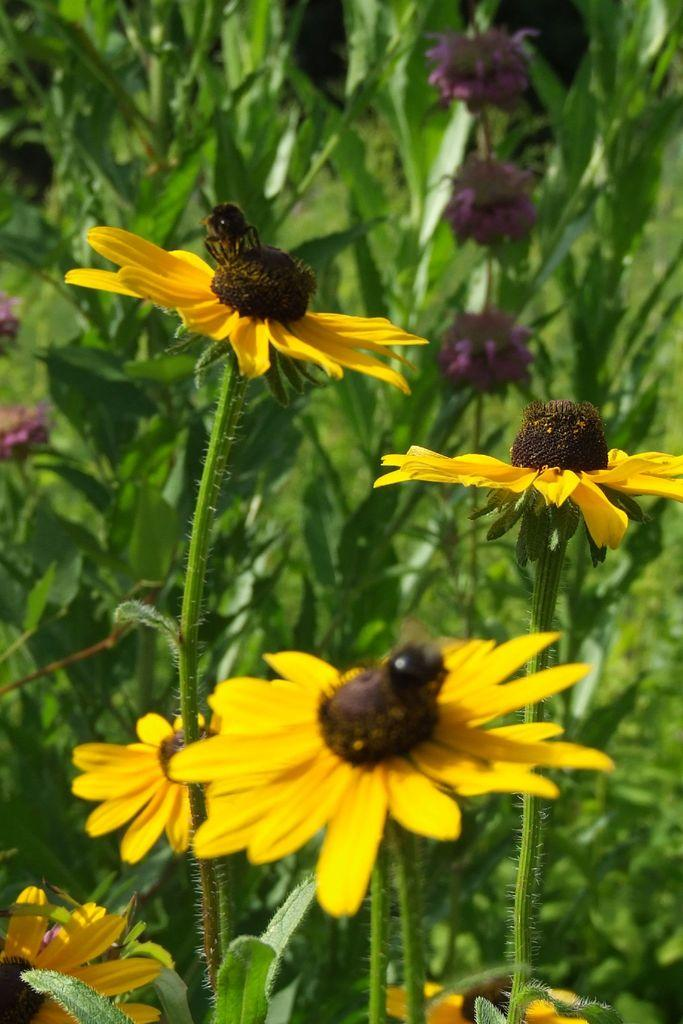What types of living organisms can be seen in the image? Flowers and plants are visible in the image. Are there any insects present on the flowers? Yes, insects are present on the flowers in the image. What type of linen can be seen draped over the plants in the image? There is no linen present in the image; it only features flowers, plants, and insects. 